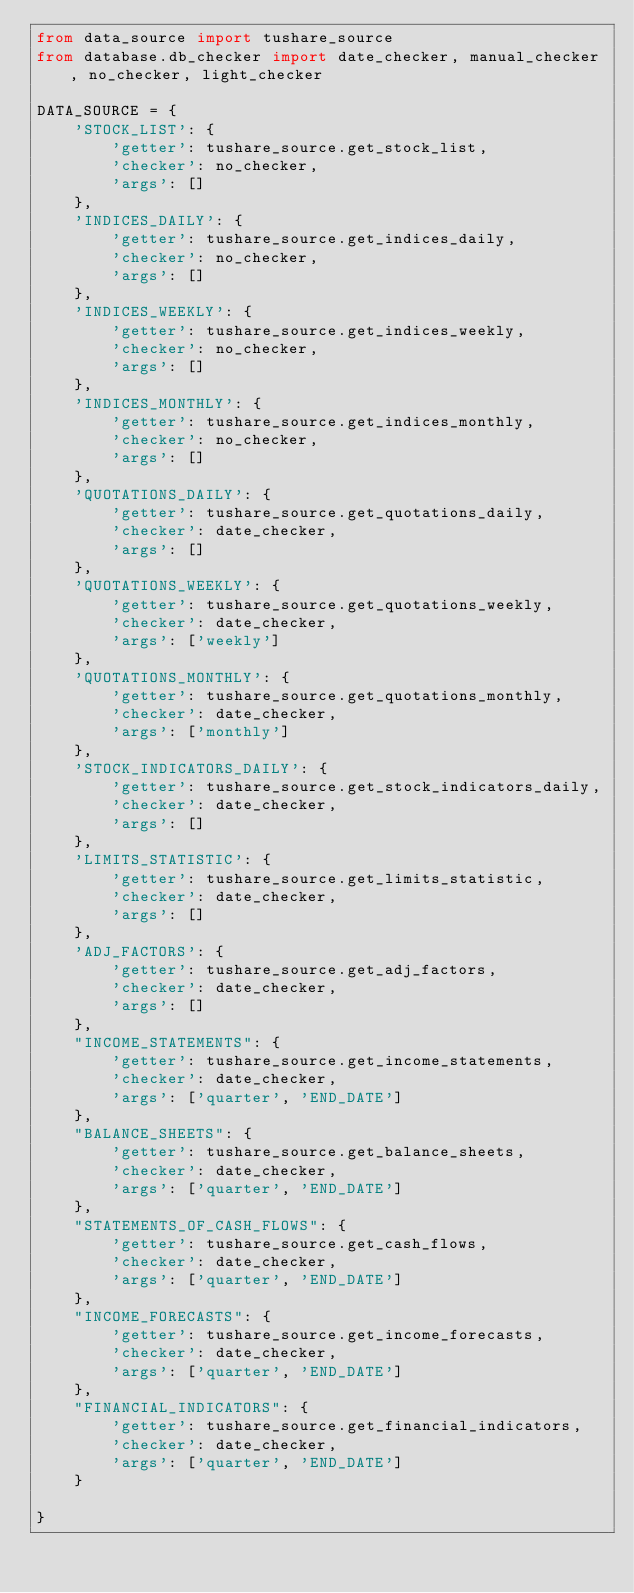<code> <loc_0><loc_0><loc_500><loc_500><_Python_>from data_source import tushare_source
from database.db_checker import date_checker, manual_checker, no_checker, light_checker

DATA_SOURCE = {
    'STOCK_LIST': {
        'getter': tushare_source.get_stock_list,
        'checker': no_checker,
        'args': []
    },
    'INDICES_DAILY': {
        'getter': tushare_source.get_indices_daily,
        'checker': no_checker,
        'args': []
    },
    'INDICES_WEEKLY': {
        'getter': tushare_source.get_indices_weekly,
        'checker': no_checker,
        'args': []
    },
    'INDICES_MONTHLY': {
        'getter': tushare_source.get_indices_monthly,
        'checker': no_checker,
        'args': []
    },
    'QUOTATIONS_DAILY': {
        'getter': tushare_source.get_quotations_daily,
        'checker': date_checker,
        'args': []
    },
    'QUOTATIONS_WEEKLY': {
        'getter': tushare_source.get_quotations_weekly,
        'checker': date_checker,
        'args': ['weekly']
    },
    'QUOTATIONS_MONTHLY': {
        'getter': tushare_source.get_quotations_monthly,
        'checker': date_checker,
        'args': ['monthly']
    },
    'STOCK_INDICATORS_DAILY': {
        'getter': tushare_source.get_stock_indicators_daily,
        'checker': date_checker,
        'args': []
    },
    'LIMITS_STATISTIC': {
        'getter': tushare_source.get_limits_statistic,
        'checker': date_checker,
        'args': []
    },
    'ADJ_FACTORS': {
        'getter': tushare_source.get_adj_factors,
        'checker': date_checker,
        'args': []
    },
    "INCOME_STATEMENTS": {
        'getter': tushare_source.get_income_statements,
        'checker': date_checker,
        'args': ['quarter', 'END_DATE']
    },
    "BALANCE_SHEETS": {
        'getter': tushare_source.get_balance_sheets,
        'checker': date_checker,
        'args': ['quarter', 'END_DATE']
    },
    "STATEMENTS_OF_CASH_FLOWS": {
        'getter': tushare_source.get_cash_flows,
        'checker': date_checker,
        'args': ['quarter', 'END_DATE']
    },
    "INCOME_FORECASTS": {
        'getter': tushare_source.get_income_forecasts,
        'checker': date_checker,
        'args': ['quarter', 'END_DATE']
    },
    "FINANCIAL_INDICATORS": {
        'getter': tushare_source.get_financial_indicators,
        'checker': date_checker,
        'args': ['quarter', 'END_DATE']
    }
    
}
</code> 